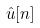Convert formula to latex. <formula><loc_0><loc_0><loc_500><loc_500>\hat { u } [ n ]</formula> 